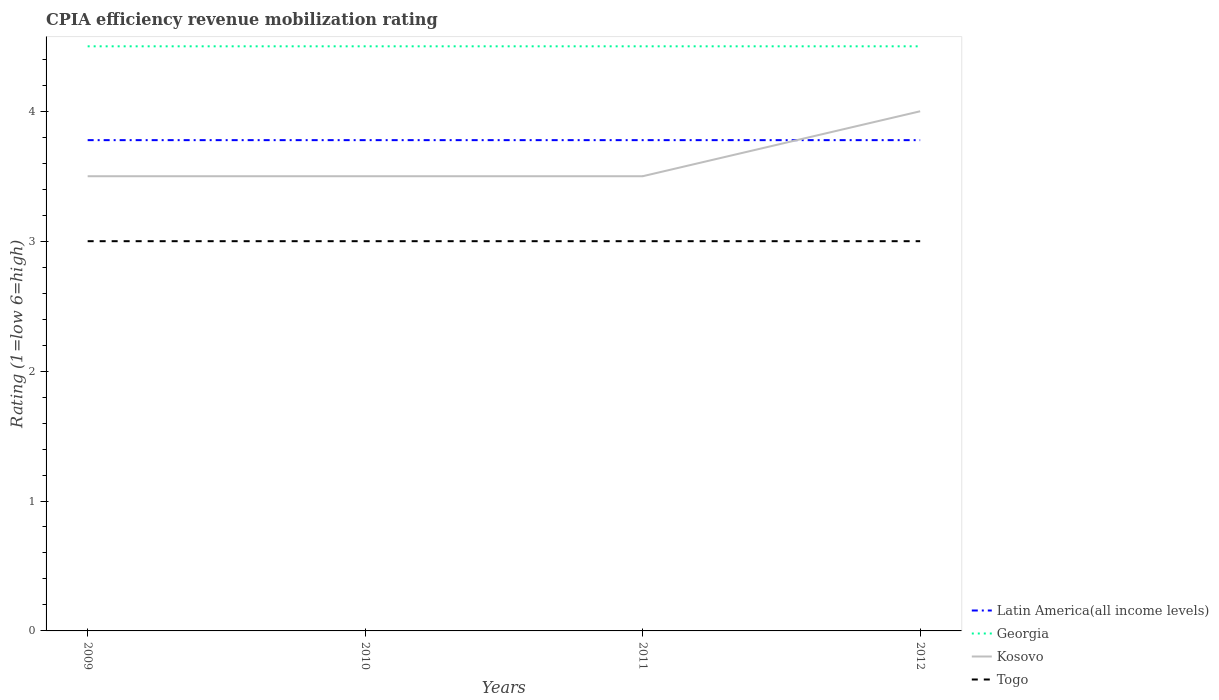How many different coloured lines are there?
Your response must be concise. 4. Is the number of lines equal to the number of legend labels?
Provide a succinct answer. Yes. Across all years, what is the maximum CPIA rating in Latin America(all income levels)?
Your response must be concise. 3.78. What is the difference between the highest and the second highest CPIA rating in Kosovo?
Provide a short and direct response. 0.5. How many lines are there?
Offer a terse response. 4. Are the values on the major ticks of Y-axis written in scientific E-notation?
Offer a terse response. No. What is the title of the graph?
Make the answer very short. CPIA efficiency revenue mobilization rating. Does "Liechtenstein" appear as one of the legend labels in the graph?
Give a very brief answer. No. What is the Rating (1=low 6=high) of Latin America(all income levels) in 2009?
Your answer should be compact. 3.78. What is the Rating (1=low 6=high) in Georgia in 2009?
Your response must be concise. 4.5. What is the Rating (1=low 6=high) in Latin America(all income levels) in 2010?
Your answer should be compact. 3.78. What is the Rating (1=low 6=high) of Georgia in 2010?
Provide a succinct answer. 4.5. What is the Rating (1=low 6=high) of Latin America(all income levels) in 2011?
Provide a succinct answer. 3.78. What is the Rating (1=low 6=high) of Kosovo in 2011?
Your answer should be compact. 3.5. What is the Rating (1=low 6=high) of Togo in 2011?
Provide a succinct answer. 3. What is the Rating (1=low 6=high) of Latin America(all income levels) in 2012?
Ensure brevity in your answer.  3.78. What is the Rating (1=low 6=high) of Georgia in 2012?
Make the answer very short. 4.5. What is the Rating (1=low 6=high) in Togo in 2012?
Keep it short and to the point. 3. Across all years, what is the maximum Rating (1=low 6=high) of Latin America(all income levels)?
Offer a terse response. 3.78. Across all years, what is the maximum Rating (1=low 6=high) of Georgia?
Offer a very short reply. 4.5. Across all years, what is the maximum Rating (1=low 6=high) in Kosovo?
Provide a short and direct response. 4. Across all years, what is the maximum Rating (1=low 6=high) in Togo?
Provide a short and direct response. 3. Across all years, what is the minimum Rating (1=low 6=high) in Latin America(all income levels)?
Your response must be concise. 3.78. Across all years, what is the minimum Rating (1=low 6=high) in Georgia?
Ensure brevity in your answer.  4.5. Across all years, what is the minimum Rating (1=low 6=high) of Togo?
Your answer should be very brief. 3. What is the total Rating (1=low 6=high) of Latin America(all income levels) in the graph?
Provide a short and direct response. 15.11. What is the total Rating (1=low 6=high) in Georgia in the graph?
Ensure brevity in your answer.  18. What is the total Rating (1=low 6=high) in Kosovo in the graph?
Provide a short and direct response. 14.5. What is the difference between the Rating (1=low 6=high) in Georgia in 2009 and that in 2010?
Your answer should be very brief. 0. What is the difference between the Rating (1=low 6=high) of Togo in 2009 and that in 2010?
Give a very brief answer. 0. What is the difference between the Rating (1=low 6=high) in Kosovo in 2009 and that in 2011?
Offer a very short reply. 0. What is the difference between the Rating (1=low 6=high) in Georgia in 2009 and that in 2012?
Keep it short and to the point. 0. What is the difference between the Rating (1=low 6=high) of Kosovo in 2009 and that in 2012?
Give a very brief answer. -0.5. What is the difference between the Rating (1=low 6=high) in Latin America(all income levels) in 2010 and that in 2011?
Keep it short and to the point. 0. What is the difference between the Rating (1=low 6=high) of Kosovo in 2010 and that in 2011?
Offer a terse response. 0. What is the difference between the Rating (1=low 6=high) of Togo in 2010 and that in 2011?
Make the answer very short. 0. What is the difference between the Rating (1=low 6=high) of Kosovo in 2010 and that in 2012?
Make the answer very short. -0.5. What is the difference between the Rating (1=low 6=high) in Togo in 2010 and that in 2012?
Make the answer very short. 0. What is the difference between the Rating (1=low 6=high) in Georgia in 2011 and that in 2012?
Your response must be concise. 0. What is the difference between the Rating (1=low 6=high) of Kosovo in 2011 and that in 2012?
Give a very brief answer. -0.5. What is the difference between the Rating (1=low 6=high) in Togo in 2011 and that in 2012?
Make the answer very short. 0. What is the difference between the Rating (1=low 6=high) of Latin America(all income levels) in 2009 and the Rating (1=low 6=high) of Georgia in 2010?
Provide a succinct answer. -0.72. What is the difference between the Rating (1=low 6=high) in Latin America(all income levels) in 2009 and the Rating (1=low 6=high) in Kosovo in 2010?
Your answer should be very brief. 0.28. What is the difference between the Rating (1=low 6=high) of Latin America(all income levels) in 2009 and the Rating (1=low 6=high) of Togo in 2010?
Provide a succinct answer. 0.78. What is the difference between the Rating (1=low 6=high) of Georgia in 2009 and the Rating (1=low 6=high) of Togo in 2010?
Provide a short and direct response. 1.5. What is the difference between the Rating (1=low 6=high) of Latin America(all income levels) in 2009 and the Rating (1=low 6=high) of Georgia in 2011?
Your answer should be very brief. -0.72. What is the difference between the Rating (1=low 6=high) of Latin America(all income levels) in 2009 and the Rating (1=low 6=high) of Kosovo in 2011?
Make the answer very short. 0.28. What is the difference between the Rating (1=low 6=high) in Georgia in 2009 and the Rating (1=low 6=high) in Togo in 2011?
Provide a short and direct response. 1.5. What is the difference between the Rating (1=low 6=high) in Latin America(all income levels) in 2009 and the Rating (1=low 6=high) in Georgia in 2012?
Make the answer very short. -0.72. What is the difference between the Rating (1=low 6=high) of Latin America(all income levels) in 2009 and the Rating (1=low 6=high) of Kosovo in 2012?
Give a very brief answer. -0.22. What is the difference between the Rating (1=low 6=high) in Latin America(all income levels) in 2009 and the Rating (1=low 6=high) in Togo in 2012?
Your answer should be compact. 0.78. What is the difference between the Rating (1=low 6=high) of Georgia in 2009 and the Rating (1=low 6=high) of Kosovo in 2012?
Offer a very short reply. 0.5. What is the difference between the Rating (1=low 6=high) in Latin America(all income levels) in 2010 and the Rating (1=low 6=high) in Georgia in 2011?
Your response must be concise. -0.72. What is the difference between the Rating (1=low 6=high) of Latin America(all income levels) in 2010 and the Rating (1=low 6=high) of Kosovo in 2011?
Ensure brevity in your answer.  0.28. What is the difference between the Rating (1=low 6=high) in Latin America(all income levels) in 2010 and the Rating (1=low 6=high) in Georgia in 2012?
Keep it short and to the point. -0.72. What is the difference between the Rating (1=low 6=high) in Latin America(all income levels) in 2010 and the Rating (1=low 6=high) in Kosovo in 2012?
Keep it short and to the point. -0.22. What is the difference between the Rating (1=low 6=high) in Latin America(all income levels) in 2011 and the Rating (1=low 6=high) in Georgia in 2012?
Provide a short and direct response. -0.72. What is the difference between the Rating (1=low 6=high) of Latin America(all income levels) in 2011 and the Rating (1=low 6=high) of Kosovo in 2012?
Provide a succinct answer. -0.22. What is the difference between the Rating (1=low 6=high) of Latin America(all income levels) in 2011 and the Rating (1=low 6=high) of Togo in 2012?
Offer a very short reply. 0.78. What is the difference between the Rating (1=low 6=high) of Georgia in 2011 and the Rating (1=low 6=high) of Togo in 2012?
Your answer should be very brief. 1.5. What is the average Rating (1=low 6=high) of Latin America(all income levels) per year?
Your answer should be very brief. 3.78. What is the average Rating (1=low 6=high) in Georgia per year?
Offer a very short reply. 4.5. What is the average Rating (1=low 6=high) of Kosovo per year?
Your answer should be compact. 3.62. In the year 2009, what is the difference between the Rating (1=low 6=high) in Latin America(all income levels) and Rating (1=low 6=high) in Georgia?
Your answer should be compact. -0.72. In the year 2009, what is the difference between the Rating (1=low 6=high) in Latin America(all income levels) and Rating (1=low 6=high) in Kosovo?
Offer a terse response. 0.28. In the year 2010, what is the difference between the Rating (1=low 6=high) of Latin America(all income levels) and Rating (1=low 6=high) of Georgia?
Make the answer very short. -0.72. In the year 2010, what is the difference between the Rating (1=low 6=high) of Latin America(all income levels) and Rating (1=low 6=high) of Kosovo?
Your answer should be compact. 0.28. In the year 2010, what is the difference between the Rating (1=low 6=high) of Latin America(all income levels) and Rating (1=low 6=high) of Togo?
Your answer should be very brief. 0.78. In the year 2011, what is the difference between the Rating (1=low 6=high) of Latin America(all income levels) and Rating (1=low 6=high) of Georgia?
Your answer should be compact. -0.72. In the year 2011, what is the difference between the Rating (1=low 6=high) of Latin America(all income levels) and Rating (1=low 6=high) of Kosovo?
Make the answer very short. 0.28. In the year 2011, what is the difference between the Rating (1=low 6=high) in Kosovo and Rating (1=low 6=high) in Togo?
Provide a short and direct response. 0.5. In the year 2012, what is the difference between the Rating (1=low 6=high) in Latin America(all income levels) and Rating (1=low 6=high) in Georgia?
Make the answer very short. -0.72. In the year 2012, what is the difference between the Rating (1=low 6=high) in Latin America(all income levels) and Rating (1=low 6=high) in Kosovo?
Offer a terse response. -0.22. In the year 2012, what is the difference between the Rating (1=low 6=high) of Kosovo and Rating (1=low 6=high) of Togo?
Offer a very short reply. 1. What is the ratio of the Rating (1=low 6=high) in Latin America(all income levels) in 2009 to that in 2010?
Keep it short and to the point. 1. What is the ratio of the Rating (1=low 6=high) of Kosovo in 2009 to that in 2010?
Offer a terse response. 1. What is the ratio of the Rating (1=low 6=high) in Togo in 2009 to that in 2010?
Offer a very short reply. 1. What is the ratio of the Rating (1=low 6=high) of Georgia in 2009 to that in 2011?
Ensure brevity in your answer.  1. What is the ratio of the Rating (1=low 6=high) in Kosovo in 2009 to that in 2011?
Ensure brevity in your answer.  1. What is the ratio of the Rating (1=low 6=high) of Georgia in 2009 to that in 2012?
Provide a succinct answer. 1. What is the ratio of the Rating (1=low 6=high) of Kosovo in 2009 to that in 2012?
Make the answer very short. 0.88. What is the ratio of the Rating (1=low 6=high) of Latin America(all income levels) in 2010 to that in 2011?
Offer a terse response. 1. What is the ratio of the Rating (1=low 6=high) in Georgia in 2010 to that in 2011?
Provide a succinct answer. 1. What is the ratio of the Rating (1=low 6=high) of Kosovo in 2010 to that in 2011?
Make the answer very short. 1. What is the ratio of the Rating (1=low 6=high) in Togo in 2010 to that in 2011?
Provide a short and direct response. 1. What is the ratio of the Rating (1=low 6=high) of Georgia in 2010 to that in 2012?
Provide a succinct answer. 1. What is the ratio of the Rating (1=low 6=high) of Togo in 2010 to that in 2012?
Your answer should be very brief. 1. What is the ratio of the Rating (1=low 6=high) in Georgia in 2011 to that in 2012?
Your answer should be very brief. 1. What is the ratio of the Rating (1=low 6=high) in Kosovo in 2011 to that in 2012?
Keep it short and to the point. 0.88. What is the difference between the highest and the second highest Rating (1=low 6=high) of Latin America(all income levels)?
Make the answer very short. 0. What is the difference between the highest and the second highest Rating (1=low 6=high) of Georgia?
Keep it short and to the point. 0. What is the difference between the highest and the lowest Rating (1=low 6=high) of Georgia?
Provide a succinct answer. 0. What is the difference between the highest and the lowest Rating (1=low 6=high) of Togo?
Provide a short and direct response. 0. 